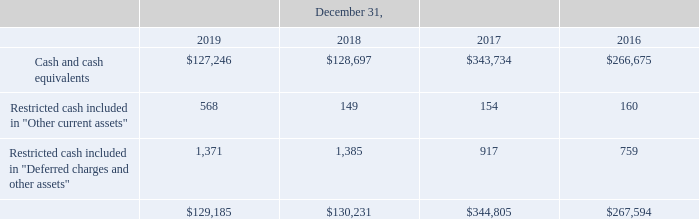Cash, Cash Equivalents and Restricted cash — Cash and cash equivalents consist of cash and highly liquid shortterm investments, primarily held in non-interest-bearing investments which have original maturities of less than 90 days. Cash and cash equivalents in the amount of $127.2 million and $128.7 million at December 31, 2019 and 2018, respectively, were primarily held in non-interest-bearing accounts. Cash and cash equivalents of $125.3 million and $115.7 million at December 31, 2019 and 2018, respectively, were held in international operations. Most of these funds will not be subject to additional taxes if repatriated to the United States. There are circumstances where the Company may be unable to repatriate some of the cash and cash equivalents held by its international operations due to country restrictions.
Restricted cash includes cash whereby the Company’s ability to use the funds at any time is contractually limited or is generally designated for specific purposes arising out of certain contractual or other obligations.
The following table provides a reconciliation of cash and cash equivalents and restricted cash reported in the Consolidated Balance Sheets that sum to the amounts reported in the Consolidated Statements of Cash Flows (in thousands):
What was the amount of cash and cash equivalents in 2019? $127.2 million. What does restricted cash include? Includes cash whereby the company’s ability to use the funds at any time is contractually limited or is generally designated for specific purposes arising out of certain contractual or other obligations. In which years was Cash and cash equivalents calculated? 2019, 2018, 2017, 2016. In which year was Restricted cash included in "Other current assets" the lowest? 149<154<160<568
Answer: 2018. What was the change in Restricted cash included in "Deferred charges and other assets" in 2017 from 2016?
Answer scale should be: thousand. 917-759
Answer: 158. What was the percentage change in Restricted cash included in "Deferred charges and other assets" in 2017 from 2016?
Answer scale should be: percent. (917-759)/759
Answer: 20.82. 